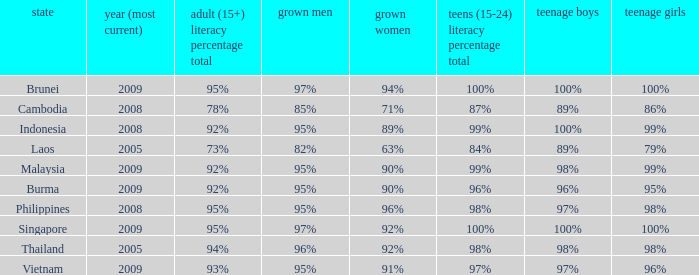Which country has a Youth (15-24) Literacy Rate Total of 100% and has an Adult Women Literacy rate of 92%? Singapore. 